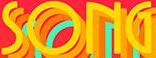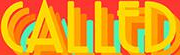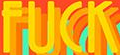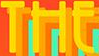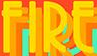What text appears in these images from left to right, separated by a semicolon? SONG; CALLED; FUCK; THE; FIRE 